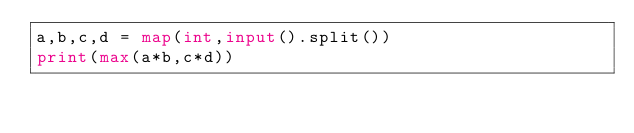<code> <loc_0><loc_0><loc_500><loc_500><_Python_>a,b,c,d = map(int,input().split())
print(max(a*b,c*d))</code> 